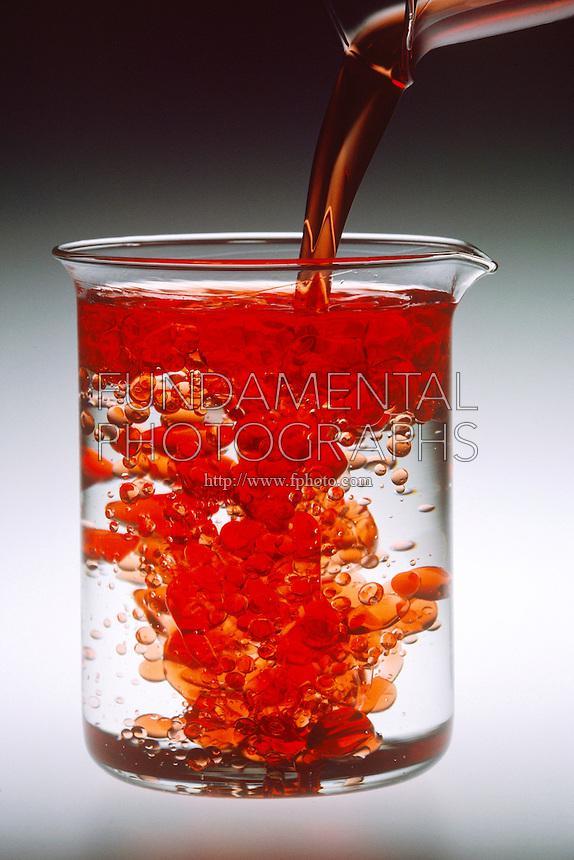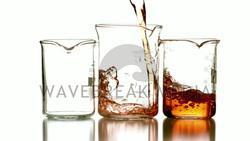The first image is the image on the left, the second image is the image on the right. Assess this claim about the two images: "There are substances in three containers in the image on the left.". Correct or not? Answer yes or no. No. The first image is the image on the left, the second image is the image on the right. Assess this claim about the two images: "One image shows colored liquid pouring into a glass, and the image contains just one glass.". Correct or not? Answer yes or no. Yes. 